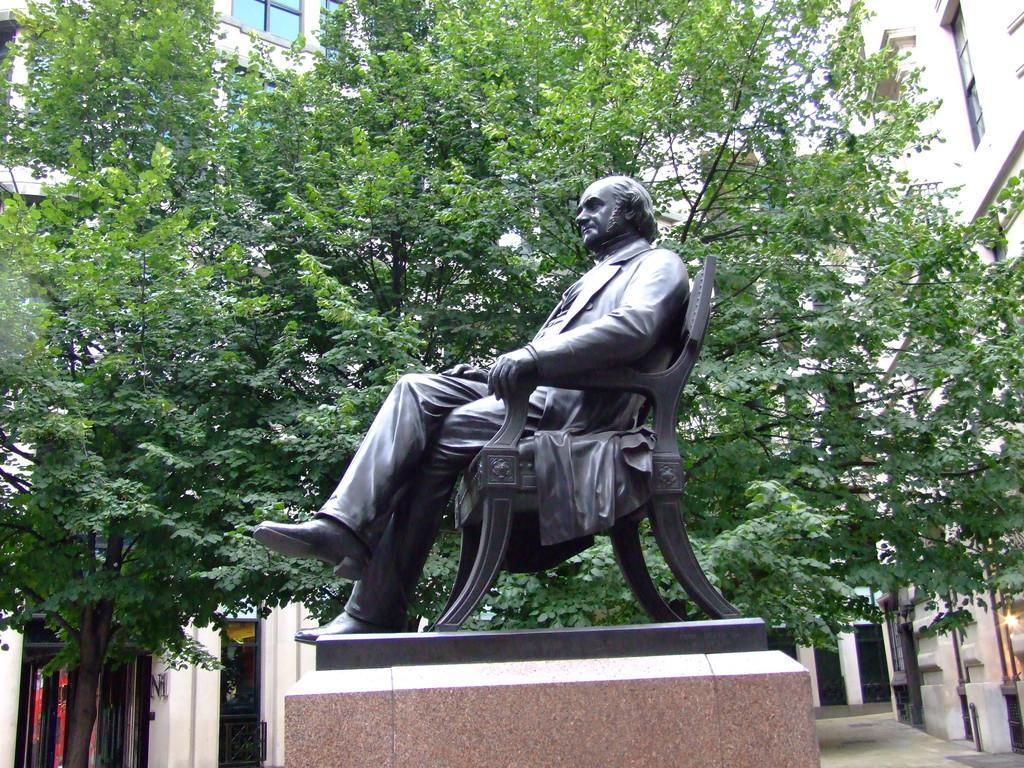What is the main subject of the image? There is a statue in the image. Can you describe the statue? The statue is of a person sitting on a chair. What can be seen in the background of the image? There are buildings and trees in the background of the image. What type of coast can be seen in the image? There is no coast visible in the image; it features a statue of a person sitting on a chair with buildings and trees in the background. 